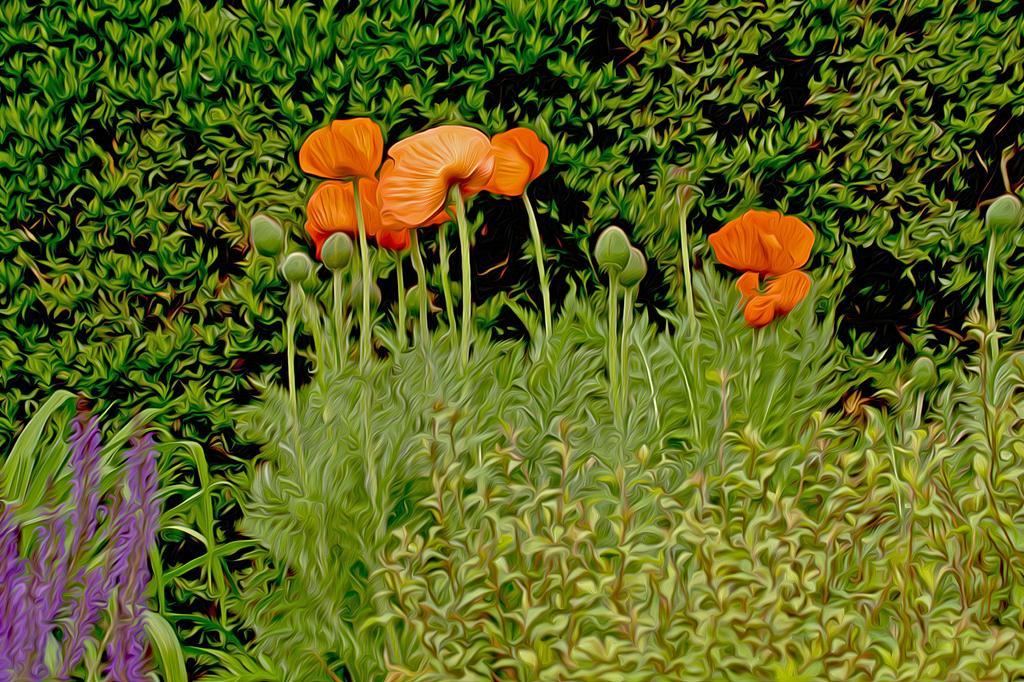Could you give a brief overview of what you see in this image? In this image there are plants, there are buds, there are flowers. 